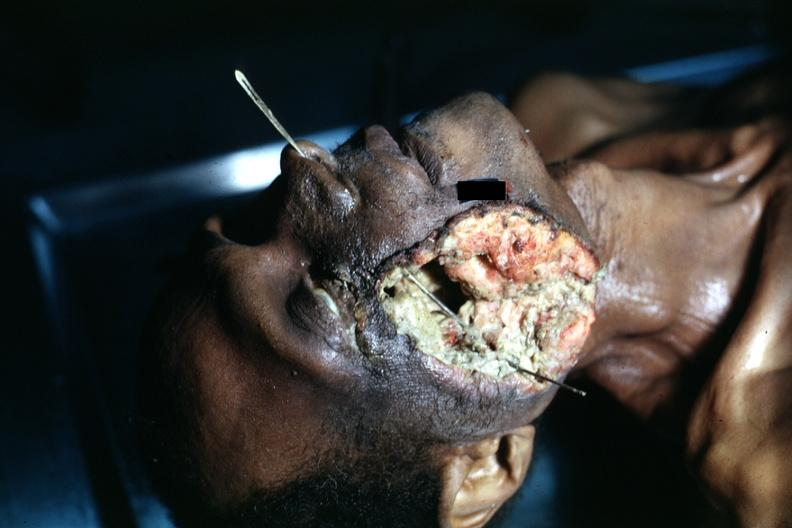what is present?
Answer the question using a single word or phrase. Maxillary sinus 